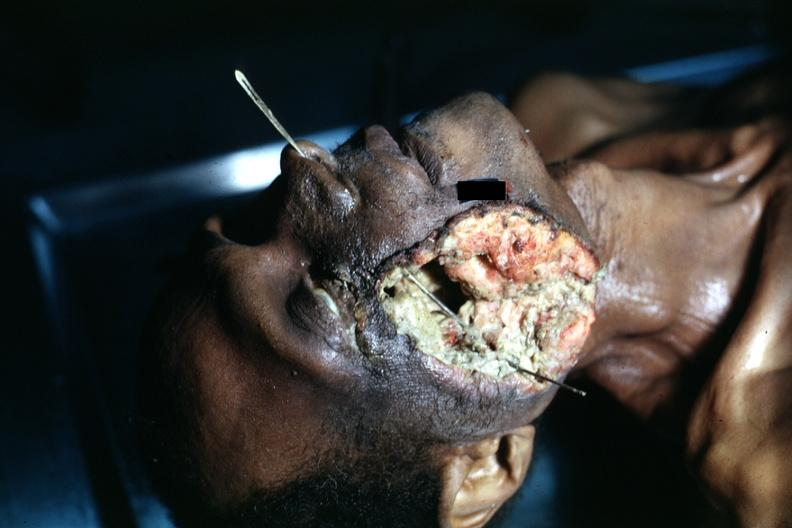what is present?
Answer the question using a single word or phrase. Maxillary sinus 